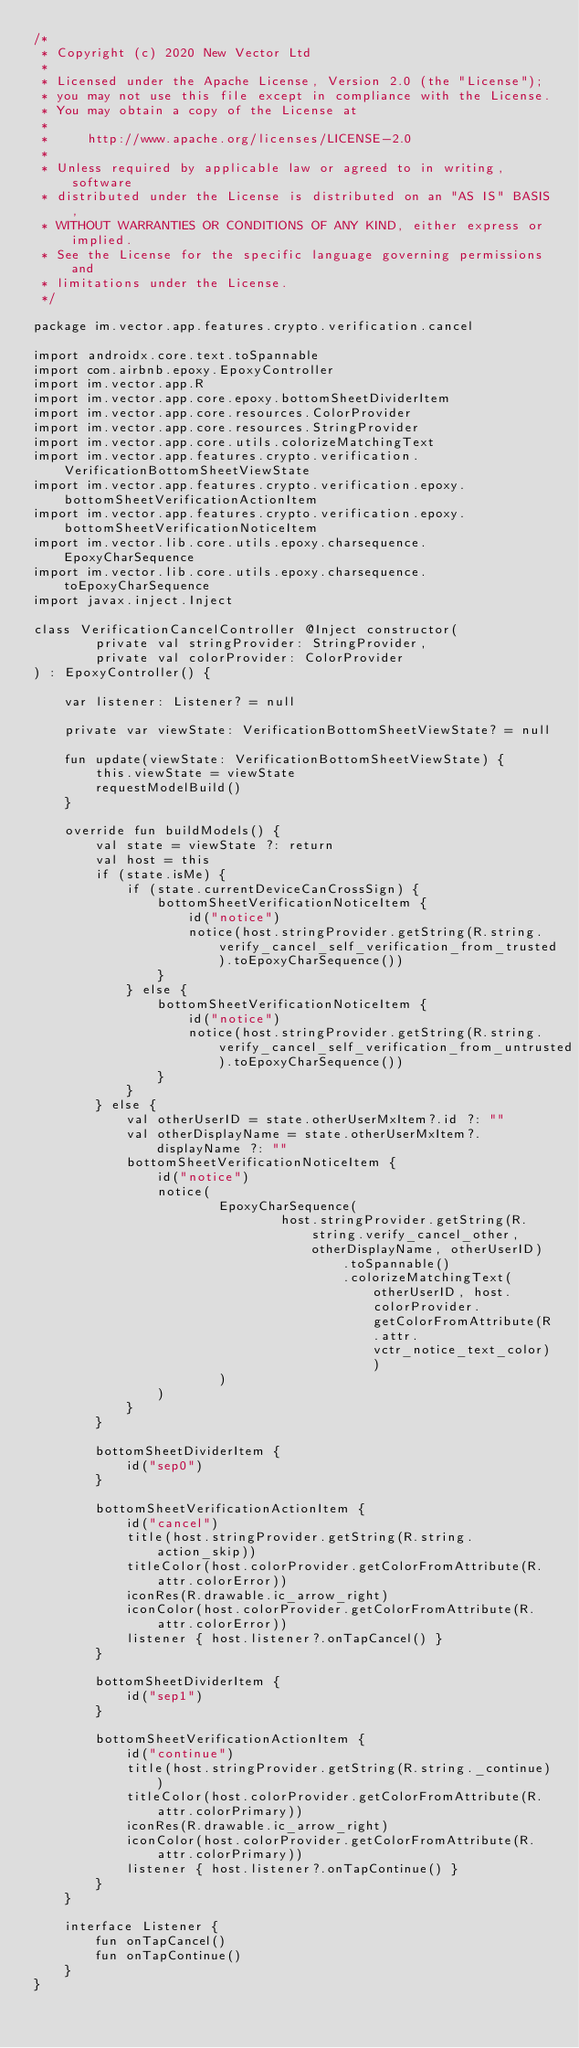<code> <loc_0><loc_0><loc_500><loc_500><_Kotlin_>/*
 * Copyright (c) 2020 New Vector Ltd
 *
 * Licensed under the Apache License, Version 2.0 (the "License");
 * you may not use this file except in compliance with the License.
 * You may obtain a copy of the License at
 *
 *     http://www.apache.org/licenses/LICENSE-2.0
 *
 * Unless required by applicable law or agreed to in writing, software
 * distributed under the License is distributed on an "AS IS" BASIS,
 * WITHOUT WARRANTIES OR CONDITIONS OF ANY KIND, either express or implied.
 * See the License for the specific language governing permissions and
 * limitations under the License.
 */

package im.vector.app.features.crypto.verification.cancel

import androidx.core.text.toSpannable
import com.airbnb.epoxy.EpoxyController
import im.vector.app.R
import im.vector.app.core.epoxy.bottomSheetDividerItem
import im.vector.app.core.resources.ColorProvider
import im.vector.app.core.resources.StringProvider
import im.vector.app.core.utils.colorizeMatchingText
import im.vector.app.features.crypto.verification.VerificationBottomSheetViewState
import im.vector.app.features.crypto.verification.epoxy.bottomSheetVerificationActionItem
import im.vector.app.features.crypto.verification.epoxy.bottomSheetVerificationNoticeItem
import im.vector.lib.core.utils.epoxy.charsequence.EpoxyCharSequence
import im.vector.lib.core.utils.epoxy.charsequence.toEpoxyCharSequence
import javax.inject.Inject

class VerificationCancelController @Inject constructor(
        private val stringProvider: StringProvider,
        private val colorProvider: ColorProvider
) : EpoxyController() {

    var listener: Listener? = null

    private var viewState: VerificationBottomSheetViewState? = null

    fun update(viewState: VerificationBottomSheetViewState) {
        this.viewState = viewState
        requestModelBuild()
    }

    override fun buildModels() {
        val state = viewState ?: return
        val host = this
        if (state.isMe) {
            if (state.currentDeviceCanCrossSign) {
                bottomSheetVerificationNoticeItem {
                    id("notice")
                    notice(host.stringProvider.getString(R.string.verify_cancel_self_verification_from_trusted).toEpoxyCharSequence())
                }
            } else {
                bottomSheetVerificationNoticeItem {
                    id("notice")
                    notice(host.stringProvider.getString(R.string.verify_cancel_self_verification_from_untrusted).toEpoxyCharSequence())
                }
            }
        } else {
            val otherUserID = state.otherUserMxItem?.id ?: ""
            val otherDisplayName = state.otherUserMxItem?.displayName ?: ""
            bottomSheetVerificationNoticeItem {
                id("notice")
                notice(
                        EpoxyCharSequence(
                                host.stringProvider.getString(R.string.verify_cancel_other, otherDisplayName, otherUserID)
                                        .toSpannable()
                                        .colorizeMatchingText(otherUserID, host.colorProvider.getColorFromAttribute(R.attr.vctr_notice_text_color))
                        )
                )
            }
        }

        bottomSheetDividerItem {
            id("sep0")
        }

        bottomSheetVerificationActionItem {
            id("cancel")
            title(host.stringProvider.getString(R.string.action_skip))
            titleColor(host.colorProvider.getColorFromAttribute(R.attr.colorError))
            iconRes(R.drawable.ic_arrow_right)
            iconColor(host.colorProvider.getColorFromAttribute(R.attr.colorError))
            listener { host.listener?.onTapCancel() }
        }

        bottomSheetDividerItem {
            id("sep1")
        }

        bottomSheetVerificationActionItem {
            id("continue")
            title(host.stringProvider.getString(R.string._continue))
            titleColor(host.colorProvider.getColorFromAttribute(R.attr.colorPrimary))
            iconRes(R.drawable.ic_arrow_right)
            iconColor(host.colorProvider.getColorFromAttribute(R.attr.colorPrimary))
            listener { host.listener?.onTapContinue() }
        }
    }

    interface Listener {
        fun onTapCancel()
        fun onTapContinue()
    }
}
</code> 